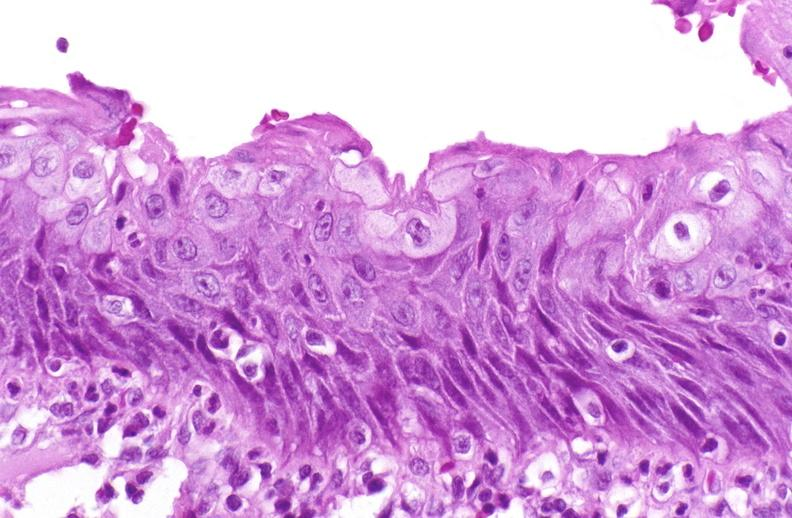what does this image show?
Answer the question using a single word or phrase. Squamous metaplasia 